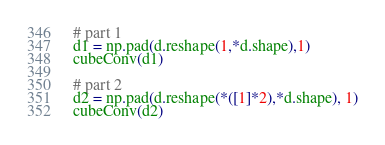Convert code to text. <code><loc_0><loc_0><loc_500><loc_500><_Python_>
# part 1
d1 = np.pad(d.reshape(1,*d.shape),1)
cubeConv(d1)

# part 2
d2 = np.pad(d.reshape(*([1]*2),*d.shape), 1)
cubeConv(d2)
</code> 